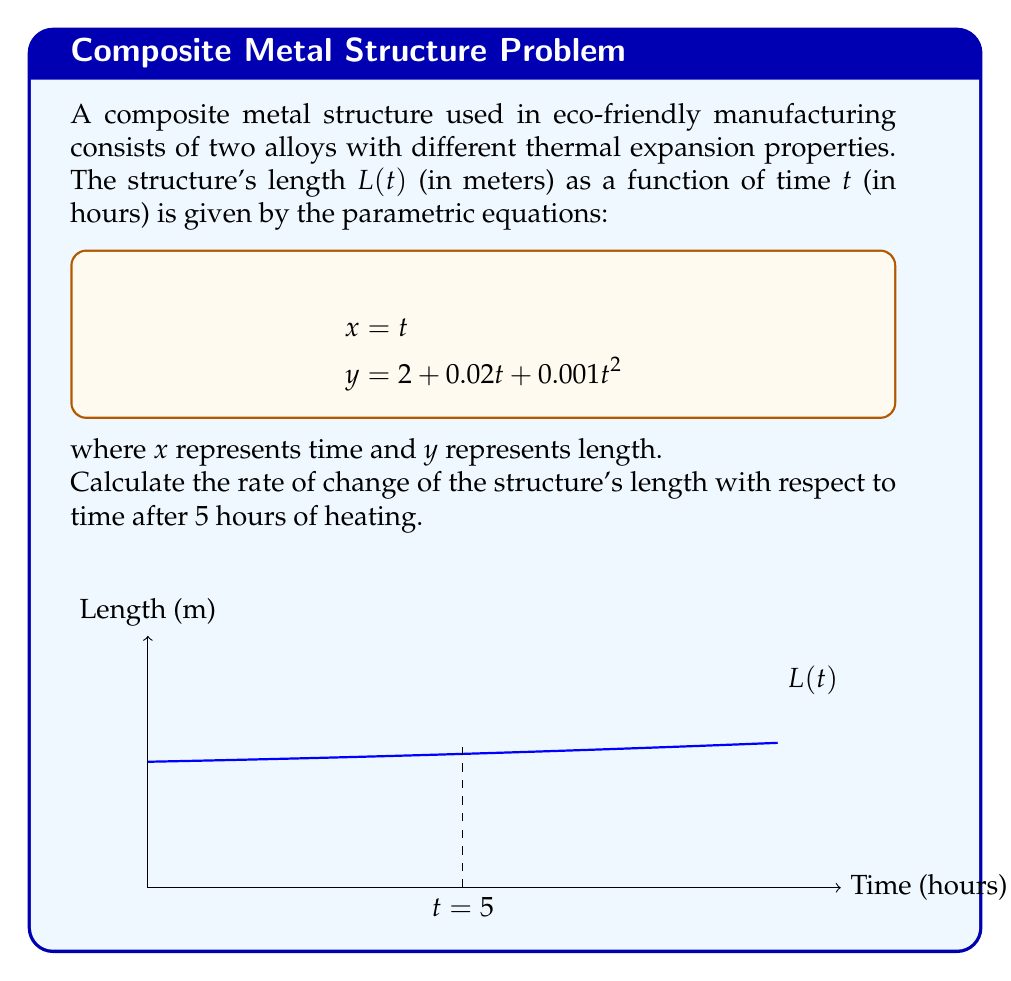Can you answer this question? To solve this problem, we need to follow these steps:

1) The parametric equations are given as:
   $$x = t$$
   $$y = 2 + 0.02t + 0.001t^2$$

2) We need to find $\frac{dy}{dx}$, which represents the rate of change of length with respect to time.

3) To do this, we can use the chain rule:
   $$\frac{dy}{dx} = \frac{dy/dt}{dx/dt}$$

4) First, let's find $\frac{dx}{dt}$:
   $$\frac{dx}{dt} = 1$$ (since $x = t$)

5) Now, let's find $\frac{dy}{dt}$:
   $$\frac{dy}{dt} = 0.02 + 0.002t$$ (derivative of $2 + 0.02t + 0.001t^2$)

6) Therefore:
   $$\frac{dy}{dx} = \frac{0.02 + 0.002t}{1} = 0.02 + 0.002t$$

7) At $t = 5$ hours:
   $$\frac{dy}{dx} = 0.02 + 0.002(5) = 0.02 + 0.01 = 0.03$$

Thus, after 5 hours of heating, the rate of change of the structure's length is 0.03 m/hour.
Answer: 0.03 m/hour 